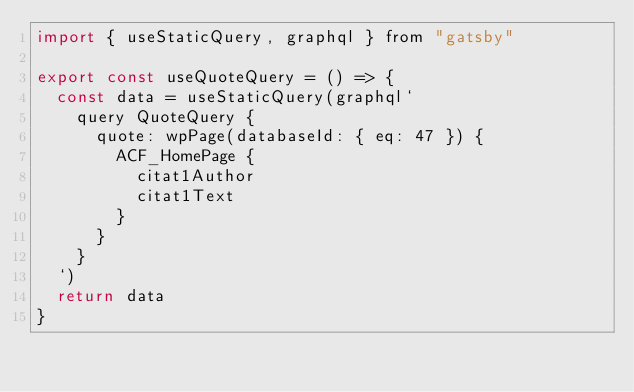Convert code to text. <code><loc_0><loc_0><loc_500><loc_500><_JavaScript_>import { useStaticQuery, graphql } from "gatsby"

export const useQuoteQuery = () => {
  const data = useStaticQuery(graphql`
    query QuoteQuery {
      quote: wpPage(databaseId: { eq: 47 }) {
        ACF_HomePage {
          citat1Author
          citat1Text
        }
      }
    }
  `)
  return data
}
</code> 